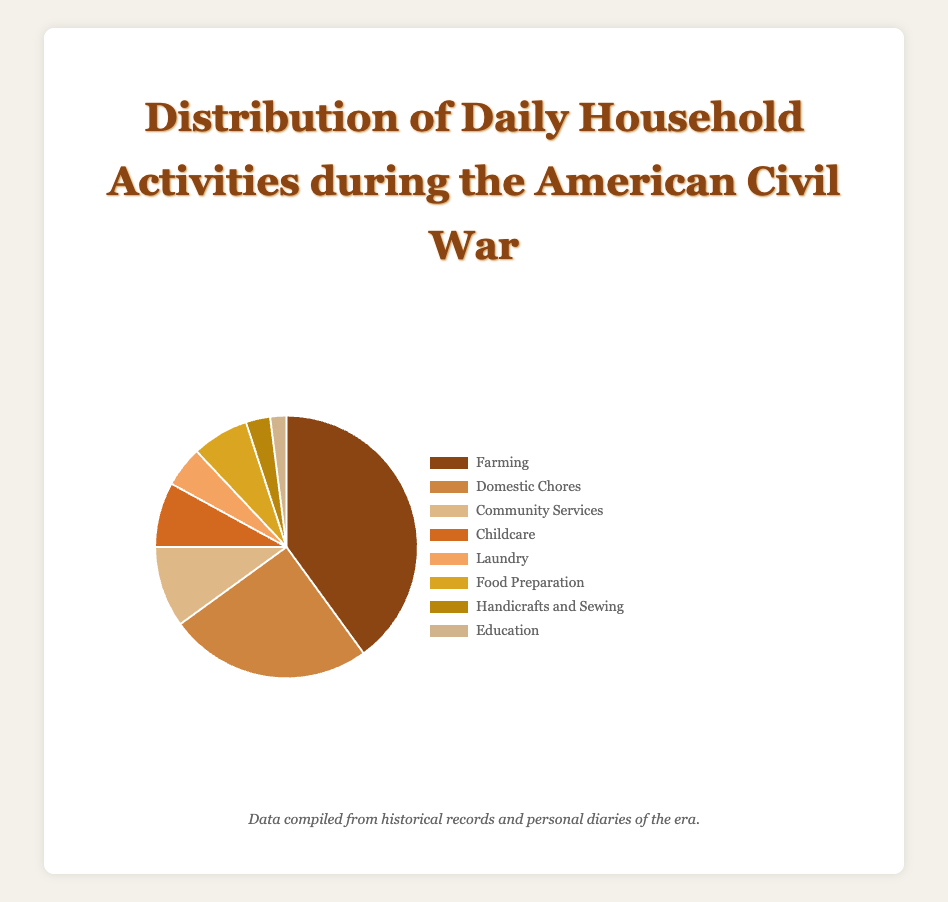What daily household activity occupied the largest percentage of time during the American Civil War? The chart shows that "Farming" has the largest slice, which corresponds to 40%.
Answer: Farming Which two activities combined make up half of the daily household activities? "Farming" (40%) and "Domestic Chores" (25%) together account for 40% + 25% = 65%, which is more than half. Thus, no combination sums exactly to half, but these two are closest.
Answer: Farming and Domestic Chores How much time was dedicated to Education compared to Laundry? Education is represented by 2%, whereas Laundry is represented by 5%. Since 5% is greater than 2%, more time was dedicated to Laundry.
Answer: Laundry What is the total percentage dedicated to activities related to childcare and education combined? Childcare accounts for 8% and Education accounts for 2%. Thus, combined, these activities take up 8% + 2% = 10%.
Answer: 10% What percentage of the day was spent on activities other than Farming, Domestic Chores, and Community Services? Farming (40%), Domestic Chores (25%), and Community Services (10%) combined account for 40% + 25% + 10% = 75%. Thus, the remaining percentage is 100% - 75% = 25%.
Answer: 25% Which activities occupy exactly 5% or less of the daily household activities? The chart shows "Laundry" at 5%, "Handicrafts and Sewing" at 3%, and "Education" at 2%.
Answer: Laundry, Handicrafts and Sewing, Education Is more time spent on Childcare or Food Preparation? Childcare occupies 8% and Food Preparation occupies 7%. Since 8% is greater than 7%, more time is spent on Childcare.
Answer: Childcare How much more time is spent on Domestic Chores compared to Community Services? Domestic Chores account for 25%, and Community Services account for 10%. The difference is 25% - 10% = 15%.
Answer: 15% What is the average percentage for all categories listed? Adding the percentages: 40 + 25 + 10 + 8 + 5 + 7 + 3 + 2 = 100. There are 8 categories, so the average is 100 / 8 = 12.5%.
Answer: 12.5% 